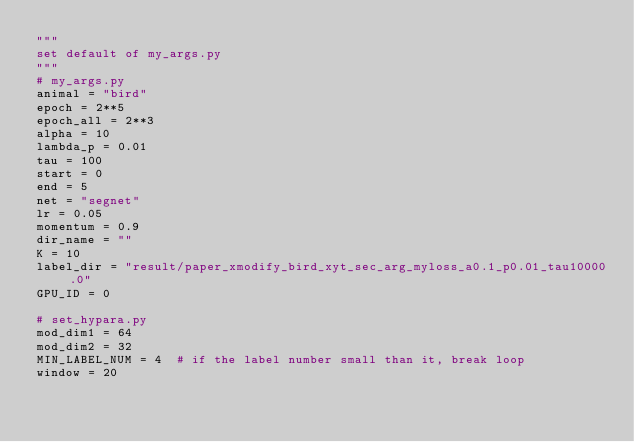<code> <loc_0><loc_0><loc_500><loc_500><_Python_>"""
set default of my_args.py
"""
# my_args.py
animal = "bird"
epoch = 2**5
epoch_all = 2**3
alpha = 10
lambda_p = 0.01
tau = 100
start = 0
end = 5
net = "segnet"
lr = 0.05
momentum = 0.9
dir_name = ""
K = 10
label_dir = "result/paper_xmodify_bird_xyt_sec_arg_myloss_a0.1_p0.01_tau10000.0"
GPU_ID = 0

# set_hypara.py
mod_dim1 = 64
mod_dim2 = 32
MIN_LABEL_NUM = 4  # if the label number small than it, break loop
window = 20</code> 